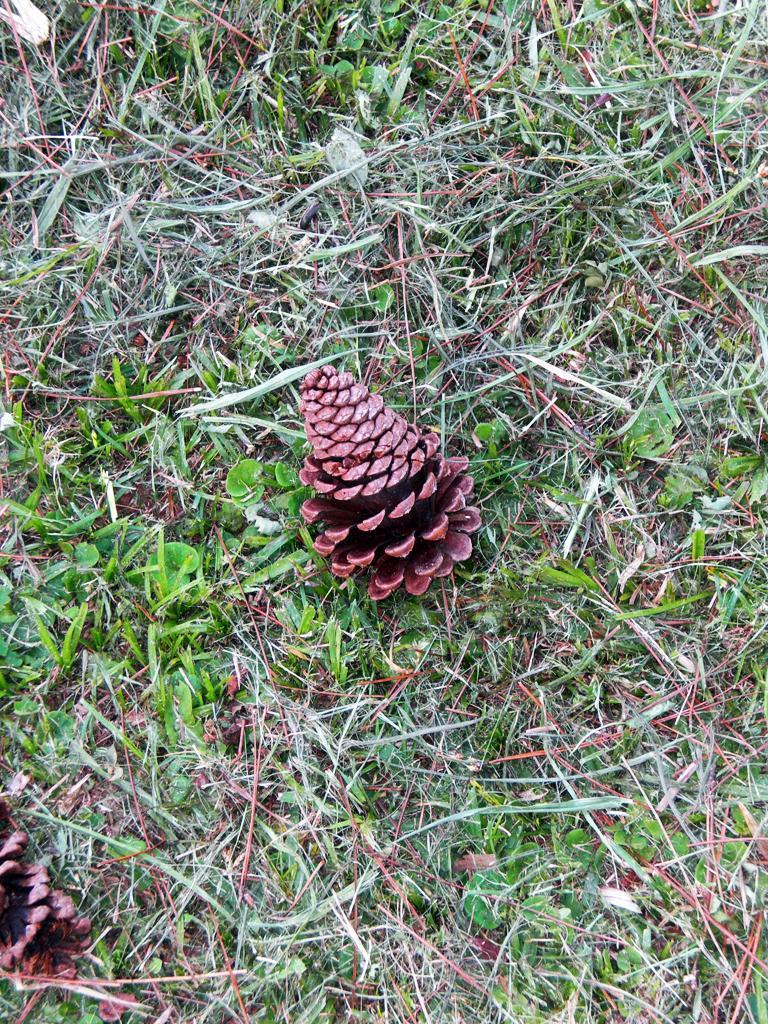Could you give a brief overview of what you see in this image? In this image we can see some pine fruits on the grass, we can also see some plants. 